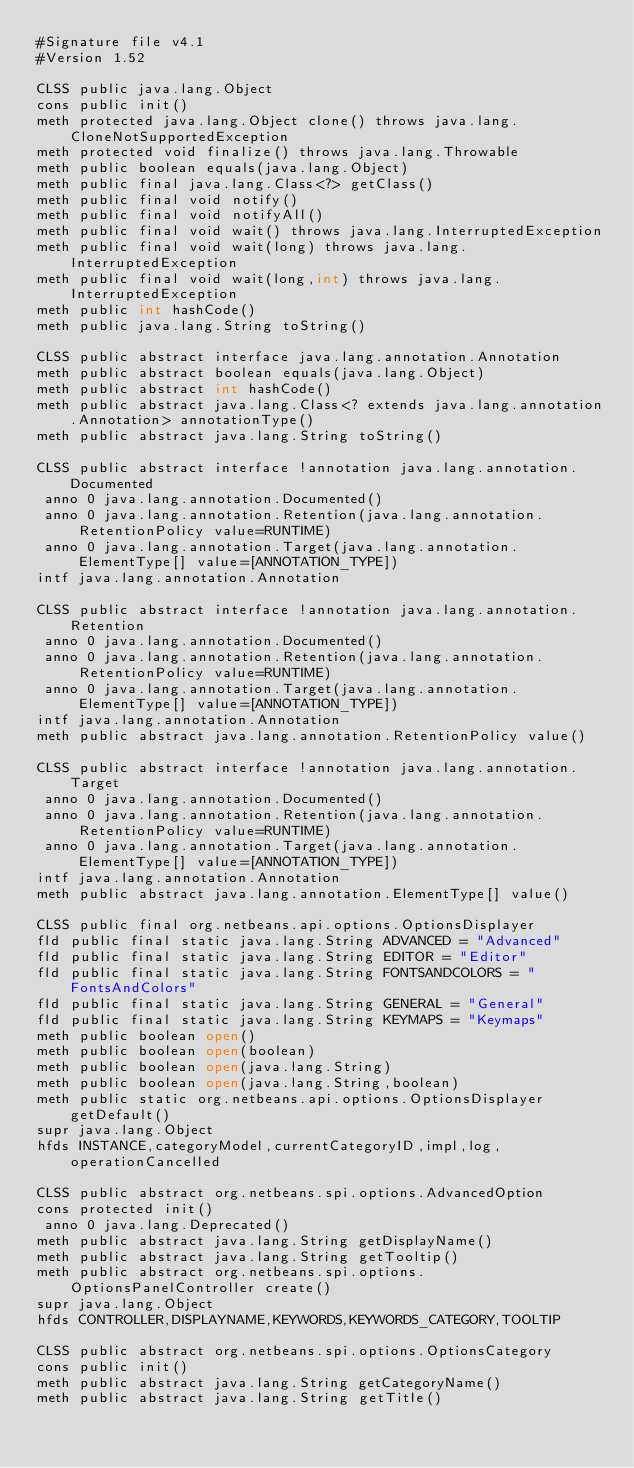Convert code to text. <code><loc_0><loc_0><loc_500><loc_500><_SML_>#Signature file v4.1
#Version 1.52

CLSS public java.lang.Object
cons public init()
meth protected java.lang.Object clone() throws java.lang.CloneNotSupportedException
meth protected void finalize() throws java.lang.Throwable
meth public boolean equals(java.lang.Object)
meth public final java.lang.Class<?> getClass()
meth public final void notify()
meth public final void notifyAll()
meth public final void wait() throws java.lang.InterruptedException
meth public final void wait(long) throws java.lang.InterruptedException
meth public final void wait(long,int) throws java.lang.InterruptedException
meth public int hashCode()
meth public java.lang.String toString()

CLSS public abstract interface java.lang.annotation.Annotation
meth public abstract boolean equals(java.lang.Object)
meth public abstract int hashCode()
meth public abstract java.lang.Class<? extends java.lang.annotation.Annotation> annotationType()
meth public abstract java.lang.String toString()

CLSS public abstract interface !annotation java.lang.annotation.Documented
 anno 0 java.lang.annotation.Documented()
 anno 0 java.lang.annotation.Retention(java.lang.annotation.RetentionPolicy value=RUNTIME)
 anno 0 java.lang.annotation.Target(java.lang.annotation.ElementType[] value=[ANNOTATION_TYPE])
intf java.lang.annotation.Annotation

CLSS public abstract interface !annotation java.lang.annotation.Retention
 anno 0 java.lang.annotation.Documented()
 anno 0 java.lang.annotation.Retention(java.lang.annotation.RetentionPolicy value=RUNTIME)
 anno 0 java.lang.annotation.Target(java.lang.annotation.ElementType[] value=[ANNOTATION_TYPE])
intf java.lang.annotation.Annotation
meth public abstract java.lang.annotation.RetentionPolicy value()

CLSS public abstract interface !annotation java.lang.annotation.Target
 anno 0 java.lang.annotation.Documented()
 anno 0 java.lang.annotation.Retention(java.lang.annotation.RetentionPolicy value=RUNTIME)
 anno 0 java.lang.annotation.Target(java.lang.annotation.ElementType[] value=[ANNOTATION_TYPE])
intf java.lang.annotation.Annotation
meth public abstract java.lang.annotation.ElementType[] value()

CLSS public final org.netbeans.api.options.OptionsDisplayer
fld public final static java.lang.String ADVANCED = "Advanced"
fld public final static java.lang.String EDITOR = "Editor"
fld public final static java.lang.String FONTSANDCOLORS = "FontsAndColors"
fld public final static java.lang.String GENERAL = "General"
fld public final static java.lang.String KEYMAPS = "Keymaps"
meth public boolean open()
meth public boolean open(boolean)
meth public boolean open(java.lang.String)
meth public boolean open(java.lang.String,boolean)
meth public static org.netbeans.api.options.OptionsDisplayer getDefault()
supr java.lang.Object
hfds INSTANCE,categoryModel,currentCategoryID,impl,log,operationCancelled

CLSS public abstract org.netbeans.spi.options.AdvancedOption
cons protected init()
 anno 0 java.lang.Deprecated()
meth public abstract java.lang.String getDisplayName()
meth public abstract java.lang.String getTooltip()
meth public abstract org.netbeans.spi.options.OptionsPanelController create()
supr java.lang.Object
hfds CONTROLLER,DISPLAYNAME,KEYWORDS,KEYWORDS_CATEGORY,TOOLTIP

CLSS public abstract org.netbeans.spi.options.OptionsCategory
cons public init()
meth public abstract java.lang.String getCategoryName()
meth public abstract java.lang.String getTitle()</code> 